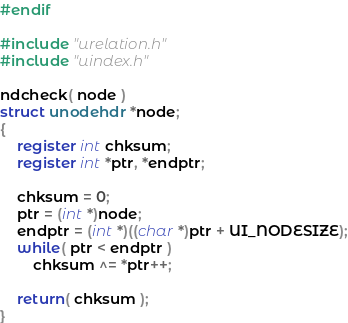Convert code to text. <code><loc_0><loc_0><loc_500><loc_500><_C_>#endif

#include "urelation.h"
#include "uindex.h"

ndcheck( node )
struct unodehdr *node;
{
	register int chksum;
	register int *ptr, *endptr;

	chksum = 0;
	ptr = (int *)node;
	endptr = (int *)((char *)ptr + UI_NODESIZE);
	while( ptr < endptr )
		chksum ^= *ptr++;

	return( chksum );
}
</code> 